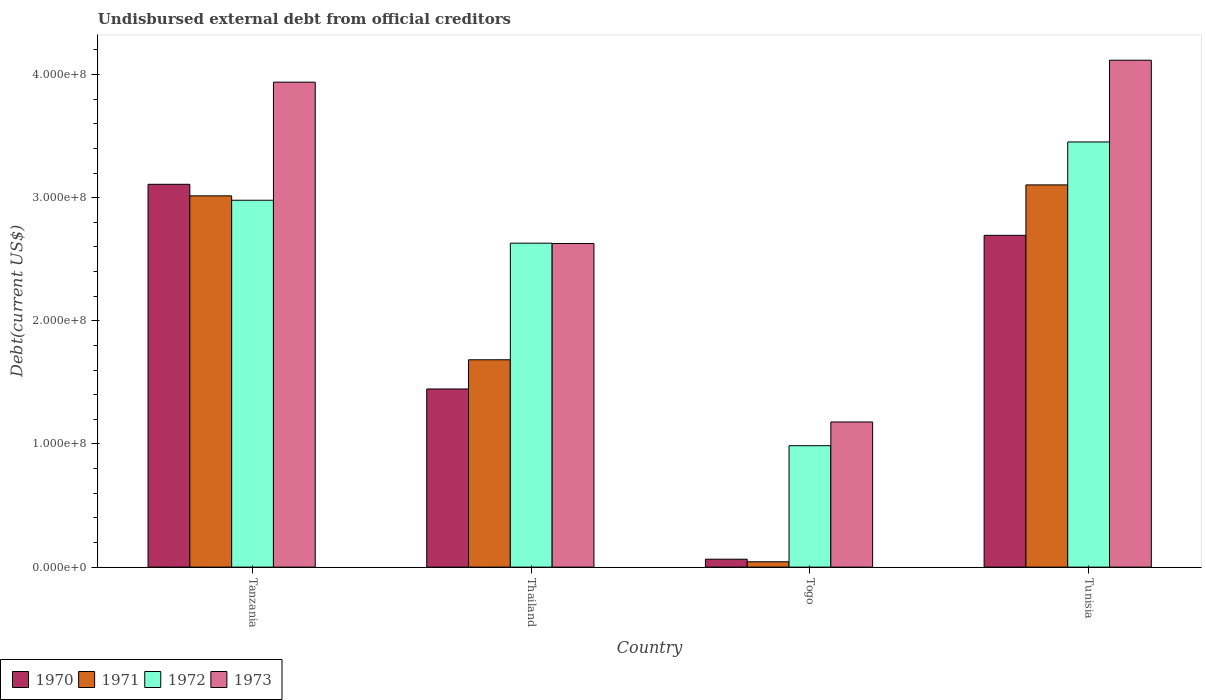How many different coloured bars are there?
Offer a terse response. 4. How many groups of bars are there?
Your answer should be very brief. 4. How many bars are there on the 4th tick from the right?
Ensure brevity in your answer.  4. What is the label of the 4th group of bars from the left?
Your answer should be very brief. Tunisia. In how many cases, is the number of bars for a given country not equal to the number of legend labels?
Your answer should be compact. 0. What is the total debt in 1973 in Tanzania?
Provide a succinct answer. 3.94e+08. Across all countries, what is the maximum total debt in 1973?
Give a very brief answer. 4.12e+08. Across all countries, what is the minimum total debt in 1970?
Offer a very short reply. 6.43e+06. In which country was the total debt in 1970 maximum?
Offer a very short reply. Tanzania. In which country was the total debt in 1971 minimum?
Offer a terse response. Togo. What is the total total debt in 1973 in the graph?
Give a very brief answer. 1.19e+09. What is the difference between the total debt in 1973 in Tanzania and that in Thailand?
Your answer should be very brief. 1.31e+08. What is the difference between the total debt in 1971 in Tanzania and the total debt in 1972 in Thailand?
Provide a short and direct response. 3.84e+07. What is the average total debt in 1970 per country?
Your response must be concise. 1.83e+08. What is the difference between the total debt of/in 1972 and total debt of/in 1970 in Tanzania?
Give a very brief answer. -1.29e+07. In how many countries, is the total debt in 1972 greater than 380000000 US$?
Keep it short and to the point. 0. What is the ratio of the total debt in 1971 in Tanzania to that in Tunisia?
Offer a very short reply. 0.97. Is the difference between the total debt in 1972 in Tanzania and Togo greater than the difference between the total debt in 1970 in Tanzania and Togo?
Your answer should be compact. No. What is the difference between the highest and the second highest total debt in 1973?
Offer a very short reply. 1.49e+08. What is the difference between the highest and the lowest total debt in 1971?
Make the answer very short. 3.06e+08. What does the 2nd bar from the left in Tunisia represents?
Your answer should be compact. 1971. What is the difference between two consecutive major ticks on the Y-axis?
Your answer should be compact. 1.00e+08. Are the values on the major ticks of Y-axis written in scientific E-notation?
Make the answer very short. Yes. What is the title of the graph?
Your answer should be compact. Undisbursed external debt from official creditors. Does "1963" appear as one of the legend labels in the graph?
Make the answer very short. No. What is the label or title of the X-axis?
Keep it short and to the point. Country. What is the label or title of the Y-axis?
Provide a short and direct response. Debt(current US$). What is the Debt(current US$) of 1970 in Tanzania?
Offer a very short reply. 3.11e+08. What is the Debt(current US$) in 1971 in Tanzania?
Make the answer very short. 3.02e+08. What is the Debt(current US$) in 1972 in Tanzania?
Offer a very short reply. 2.98e+08. What is the Debt(current US$) in 1973 in Tanzania?
Offer a very short reply. 3.94e+08. What is the Debt(current US$) in 1970 in Thailand?
Offer a very short reply. 1.45e+08. What is the Debt(current US$) of 1971 in Thailand?
Make the answer very short. 1.68e+08. What is the Debt(current US$) of 1972 in Thailand?
Make the answer very short. 2.63e+08. What is the Debt(current US$) of 1973 in Thailand?
Your answer should be very brief. 2.63e+08. What is the Debt(current US$) in 1970 in Togo?
Make the answer very short. 6.43e+06. What is the Debt(current US$) of 1971 in Togo?
Give a very brief answer. 4.34e+06. What is the Debt(current US$) of 1972 in Togo?
Keep it short and to the point. 9.86e+07. What is the Debt(current US$) of 1973 in Togo?
Keep it short and to the point. 1.18e+08. What is the Debt(current US$) in 1970 in Tunisia?
Provide a succinct answer. 2.69e+08. What is the Debt(current US$) in 1971 in Tunisia?
Your response must be concise. 3.10e+08. What is the Debt(current US$) of 1972 in Tunisia?
Offer a terse response. 3.45e+08. What is the Debt(current US$) of 1973 in Tunisia?
Your answer should be compact. 4.12e+08. Across all countries, what is the maximum Debt(current US$) of 1970?
Your answer should be very brief. 3.11e+08. Across all countries, what is the maximum Debt(current US$) in 1971?
Ensure brevity in your answer.  3.10e+08. Across all countries, what is the maximum Debt(current US$) in 1972?
Provide a short and direct response. 3.45e+08. Across all countries, what is the maximum Debt(current US$) in 1973?
Keep it short and to the point. 4.12e+08. Across all countries, what is the minimum Debt(current US$) in 1970?
Offer a terse response. 6.43e+06. Across all countries, what is the minimum Debt(current US$) of 1971?
Provide a short and direct response. 4.34e+06. Across all countries, what is the minimum Debt(current US$) in 1972?
Give a very brief answer. 9.86e+07. Across all countries, what is the minimum Debt(current US$) in 1973?
Make the answer very short. 1.18e+08. What is the total Debt(current US$) in 1970 in the graph?
Offer a terse response. 7.31e+08. What is the total Debt(current US$) in 1971 in the graph?
Offer a very short reply. 7.85e+08. What is the total Debt(current US$) in 1972 in the graph?
Your response must be concise. 1.00e+09. What is the total Debt(current US$) of 1973 in the graph?
Your answer should be compact. 1.19e+09. What is the difference between the Debt(current US$) of 1970 in Tanzania and that in Thailand?
Offer a terse response. 1.66e+08. What is the difference between the Debt(current US$) of 1971 in Tanzania and that in Thailand?
Your response must be concise. 1.33e+08. What is the difference between the Debt(current US$) in 1972 in Tanzania and that in Thailand?
Your answer should be compact. 3.49e+07. What is the difference between the Debt(current US$) in 1973 in Tanzania and that in Thailand?
Offer a very short reply. 1.31e+08. What is the difference between the Debt(current US$) in 1970 in Tanzania and that in Togo?
Offer a terse response. 3.04e+08. What is the difference between the Debt(current US$) of 1971 in Tanzania and that in Togo?
Provide a short and direct response. 2.97e+08. What is the difference between the Debt(current US$) of 1972 in Tanzania and that in Togo?
Ensure brevity in your answer.  1.99e+08. What is the difference between the Debt(current US$) in 1973 in Tanzania and that in Togo?
Ensure brevity in your answer.  2.76e+08. What is the difference between the Debt(current US$) in 1970 in Tanzania and that in Tunisia?
Keep it short and to the point. 4.14e+07. What is the difference between the Debt(current US$) of 1971 in Tanzania and that in Tunisia?
Provide a short and direct response. -8.90e+06. What is the difference between the Debt(current US$) of 1972 in Tanzania and that in Tunisia?
Your response must be concise. -4.73e+07. What is the difference between the Debt(current US$) of 1973 in Tanzania and that in Tunisia?
Your response must be concise. -1.78e+07. What is the difference between the Debt(current US$) in 1970 in Thailand and that in Togo?
Your response must be concise. 1.38e+08. What is the difference between the Debt(current US$) of 1971 in Thailand and that in Togo?
Offer a very short reply. 1.64e+08. What is the difference between the Debt(current US$) of 1972 in Thailand and that in Togo?
Your answer should be compact. 1.64e+08. What is the difference between the Debt(current US$) in 1973 in Thailand and that in Togo?
Your response must be concise. 1.45e+08. What is the difference between the Debt(current US$) in 1970 in Thailand and that in Tunisia?
Your response must be concise. -1.25e+08. What is the difference between the Debt(current US$) in 1971 in Thailand and that in Tunisia?
Provide a succinct answer. -1.42e+08. What is the difference between the Debt(current US$) of 1972 in Thailand and that in Tunisia?
Provide a succinct answer. -8.22e+07. What is the difference between the Debt(current US$) in 1973 in Thailand and that in Tunisia?
Ensure brevity in your answer.  -1.49e+08. What is the difference between the Debt(current US$) in 1970 in Togo and that in Tunisia?
Ensure brevity in your answer.  -2.63e+08. What is the difference between the Debt(current US$) of 1971 in Togo and that in Tunisia?
Your answer should be compact. -3.06e+08. What is the difference between the Debt(current US$) of 1972 in Togo and that in Tunisia?
Your answer should be very brief. -2.47e+08. What is the difference between the Debt(current US$) of 1973 in Togo and that in Tunisia?
Your answer should be compact. -2.94e+08. What is the difference between the Debt(current US$) of 1970 in Tanzania and the Debt(current US$) of 1971 in Thailand?
Provide a short and direct response. 1.42e+08. What is the difference between the Debt(current US$) in 1970 in Tanzania and the Debt(current US$) in 1972 in Thailand?
Keep it short and to the point. 4.78e+07. What is the difference between the Debt(current US$) in 1970 in Tanzania and the Debt(current US$) in 1973 in Thailand?
Give a very brief answer. 4.81e+07. What is the difference between the Debt(current US$) of 1971 in Tanzania and the Debt(current US$) of 1972 in Thailand?
Your answer should be compact. 3.84e+07. What is the difference between the Debt(current US$) of 1971 in Tanzania and the Debt(current US$) of 1973 in Thailand?
Offer a very short reply. 3.87e+07. What is the difference between the Debt(current US$) of 1972 in Tanzania and the Debt(current US$) of 1973 in Thailand?
Provide a succinct answer. 3.51e+07. What is the difference between the Debt(current US$) in 1970 in Tanzania and the Debt(current US$) in 1971 in Togo?
Your answer should be compact. 3.07e+08. What is the difference between the Debt(current US$) of 1970 in Tanzania and the Debt(current US$) of 1972 in Togo?
Your response must be concise. 2.12e+08. What is the difference between the Debt(current US$) in 1970 in Tanzania and the Debt(current US$) in 1973 in Togo?
Make the answer very short. 1.93e+08. What is the difference between the Debt(current US$) of 1971 in Tanzania and the Debt(current US$) of 1972 in Togo?
Offer a very short reply. 2.03e+08. What is the difference between the Debt(current US$) in 1971 in Tanzania and the Debt(current US$) in 1973 in Togo?
Your answer should be very brief. 1.84e+08. What is the difference between the Debt(current US$) of 1972 in Tanzania and the Debt(current US$) of 1973 in Togo?
Ensure brevity in your answer.  1.80e+08. What is the difference between the Debt(current US$) in 1970 in Tanzania and the Debt(current US$) in 1971 in Tunisia?
Ensure brevity in your answer.  4.74e+05. What is the difference between the Debt(current US$) of 1970 in Tanzania and the Debt(current US$) of 1972 in Tunisia?
Ensure brevity in your answer.  -3.44e+07. What is the difference between the Debt(current US$) in 1970 in Tanzania and the Debt(current US$) in 1973 in Tunisia?
Your answer should be very brief. -1.01e+08. What is the difference between the Debt(current US$) in 1971 in Tanzania and the Debt(current US$) in 1972 in Tunisia?
Provide a succinct answer. -4.38e+07. What is the difference between the Debt(current US$) of 1971 in Tanzania and the Debt(current US$) of 1973 in Tunisia?
Ensure brevity in your answer.  -1.10e+08. What is the difference between the Debt(current US$) in 1972 in Tanzania and the Debt(current US$) in 1973 in Tunisia?
Your answer should be compact. -1.14e+08. What is the difference between the Debt(current US$) in 1970 in Thailand and the Debt(current US$) in 1971 in Togo?
Your answer should be very brief. 1.40e+08. What is the difference between the Debt(current US$) of 1970 in Thailand and the Debt(current US$) of 1972 in Togo?
Offer a very short reply. 4.61e+07. What is the difference between the Debt(current US$) of 1970 in Thailand and the Debt(current US$) of 1973 in Togo?
Provide a succinct answer. 2.68e+07. What is the difference between the Debt(current US$) of 1971 in Thailand and the Debt(current US$) of 1972 in Togo?
Keep it short and to the point. 6.98e+07. What is the difference between the Debt(current US$) of 1971 in Thailand and the Debt(current US$) of 1973 in Togo?
Make the answer very short. 5.05e+07. What is the difference between the Debt(current US$) in 1972 in Thailand and the Debt(current US$) in 1973 in Togo?
Your response must be concise. 1.45e+08. What is the difference between the Debt(current US$) in 1970 in Thailand and the Debt(current US$) in 1971 in Tunisia?
Your response must be concise. -1.66e+08. What is the difference between the Debt(current US$) in 1970 in Thailand and the Debt(current US$) in 1972 in Tunisia?
Keep it short and to the point. -2.01e+08. What is the difference between the Debt(current US$) in 1970 in Thailand and the Debt(current US$) in 1973 in Tunisia?
Ensure brevity in your answer.  -2.67e+08. What is the difference between the Debt(current US$) of 1971 in Thailand and the Debt(current US$) of 1972 in Tunisia?
Your response must be concise. -1.77e+08. What is the difference between the Debt(current US$) in 1971 in Thailand and the Debt(current US$) in 1973 in Tunisia?
Offer a terse response. -2.43e+08. What is the difference between the Debt(current US$) of 1972 in Thailand and the Debt(current US$) of 1973 in Tunisia?
Keep it short and to the point. -1.49e+08. What is the difference between the Debt(current US$) of 1970 in Togo and the Debt(current US$) of 1971 in Tunisia?
Ensure brevity in your answer.  -3.04e+08. What is the difference between the Debt(current US$) of 1970 in Togo and the Debt(current US$) of 1972 in Tunisia?
Your answer should be very brief. -3.39e+08. What is the difference between the Debt(current US$) of 1970 in Togo and the Debt(current US$) of 1973 in Tunisia?
Offer a terse response. -4.05e+08. What is the difference between the Debt(current US$) of 1971 in Togo and the Debt(current US$) of 1972 in Tunisia?
Give a very brief answer. -3.41e+08. What is the difference between the Debt(current US$) in 1971 in Togo and the Debt(current US$) in 1973 in Tunisia?
Your answer should be compact. -4.07e+08. What is the difference between the Debt(current US$) of 1972 in Togo and the Debt(current US$) of 1973 in Tunisia?
Keep it short and to the point. -3.13e+08. What is the average Debt(current US$) of 1970 per country?
Provide a succinct answer. 1.83e+08. What is the average Debt(current US$) in 1971 per country?
Your answer should be very brief. 1.96e+08. What is the average Debt(current US$) in 1972 per country?
Give a very brief answer. 2.51e+08. What is the average Debt(current US$) of 1973 per country?
Make the answer very short. 2.97e+08. What is the difference between the Debt(current US$) in 1970 and Debt(current US$) in 1971 in Tanzania?
Your answer should be compact. 9.37e+06. What is the difference between the Debt(current US$) in 1970 and Debt(current US$) in 1972 in Tanzania?
Your answer should be very brief. 1.29e+07. What is the difference between the Debt(current US$) in 1970 and Debt(current US$) in 1973 in Tanzania?
Your response must be concise. -8.30e+07. What is the difference between the Debt(current US$) of 1971 and Debt(current US$) of 1972 in Tanzania?
Your response must be concise. 3.57e+06. What is the difference between the Debt(current US$) of 1971 and Debt(current US$) of 1973 in Tanzania?
Your response must be concise. -9.23e+07. What is the difference between the Debt(current US$) of 1972 and Debt(current US$) of 1973 in Tanzania?
Your answer should be very brief. -9.59e+07. What is the difference between the Debt(current US$) in 1970 and Debt(current US$) in 1971 in Thailand?
Provide a short and direct response. -2.37e+07. What is the difference between the Debt(current US$) in 1970 and Debt(current US$) in 1972 in Thailand?
Keep it short and to the point. -1.18e+08. What is the difference between the Debt(current US$) of 1970 and Debt(current US$) of 1973 in Thailand?
Offer a very short reply. -1.18e+08. What is the difference between the Debt(current US$) of 1971 and Debt(current US$) of 1972 in Thailand?
Offer a very short reply. -9.47e+07. What is the difference between the Debt(current US$) in 1971 and Debt(current US$) in 1973 in Thailand?
Provide a short and direct response. -9.44e+07. What is the difference between the Debt(current US$) in 1972 and Debt(current US$) in 1973 in Thailand?
Provide a succinct answer. 2.70e+05. What is the difference between the Debt(current US$) of 1970 and Debt(current US$) of 1971 in Togo?
Provide a short and direct response. 2.09e+06. What is the difference between the Debt(current US$) of 1970 and Debt(current US$) of 1972 in Togo?
Your response must be concise. -9.22e+07. What is the difference between the Debt(current US$) in 1970 and Debt(current US$) in 1973 in Togo?
Offer a terse response. -1.11e+08. What is the difference between the Debt(current US$) of 1971 and Debt(current US$) of 1972 in Togo?
Make the answer very short. -9.43e+07. What is the difference between the Debt(current US$) of 1971 and Debt(current US$) of 1973 in Togo?
Provide a short and direct response. -1.14e+08. What is the difference between the Debt(current US$) in 1972 and Debt(current US$) in 1973 in Togo?
Provide a succinct answer. -1.93e+07. What is the difference between the Debt(current US$) of 1970 and Debt(current US$) of 1971 in Tunisia?
Provide a succinct answer. -4.10e+07. What is the difference between the Debt(current US$) of 1970 and Debt(current US$) of 1972 in Tunisia?
Provide a short and direct response. -7.58e+07. What is the difference between the Debt(current US$) of 1970 and Debt(current US$) of 1973 in Tunisia?
Offer a very short reply. -1.42e+08. What is the difference between the Debt(current US$) of 1971 and Debt(current US$) of 1972 in Tunisia?
Offer a very short reply. -3.49e+07. What is the difference between the Debt(current US$) of 1971 and Debt(current US$) of 1973 in Tunisia?
Keep it short and to the point. -1.01e+08. What is the difference between the Debt(current US$) in 1972 and Debt(current US$) in 1973 in Tunisia?
Offer a terse response. -6.64e+07. What is the ratio of the Debt(current US$) of 1970 in Tanzania to that in Thailand?
Offer a terse response. 2.15. What is the ratio of the Debt(current US$) of 1971 in Tanzania to that in Thailand?
Your response must be concise. 1.79. What is the ratio of the Debt(current US$) in 1972 in Tanzania to that in Thailand?
Your response must be concise. 1.13. What is the ratio of the Debt(current US$) of 1973 in Tanzania to that in Thailand?
Ensure brevity in your answer.  1.5. What is the ratio of the Debt(current US$) of 1970 in Tanzania to that in Togo?
Offer a terse response. 48.37. What is the ratio of the Debt(current US$) of 1971 in Tanzania to that in Togo?
Keep it short and to the point. 69.54. What is the ratio of the Debt(current US$) of 1972 in Tanzania to that in Togo?
Offer a very short reply. 3.02. What is the ratio of the Debt(current US$) of 1973 in Tanzania to that in Togo?
Keep it short and to the point. 3.34. What is the ratio of the Debt(current US$) of 1970 in Tanzania to that in Tunisia?
Provide a short and direct response. 1.15. What is the ratio of the Debt(current US$) in 1971 in Tanzania to that in Tunisia?
Offer a very short reply. 0.97. What is the ratio of the Debt(current US$) of 1972 in Tanzania to that in Tunisia?
Provide a succinct answer. 0.86. What is the ratio of the Debt(current US$) in 1973 in Tanzania to that in Tunisia?
Provide a succinct answer. 0.96. What is the ratio of the Debt(current US$) in 1970 in Thailand to that in Togo?
Ensure brevity in your answer.  22.51. What is the ratio of the Debt(current US$) of 1971 in Thailand to that in Togo?
Provide a succinct answer. 38.84. What is the ratio of the Debt(current US$) in 1972 in Thailand to that in Togo?
Offer a terse response. 2.67. What is the ratio of the Debt(current US$) of 1973 in Thailand to that in Togo?
Offer a very short reply. 2.23. What is the ratio of the Debt(current US$) in 1970 in Thailand to that in Tunisia?
Keep it short and to the point. 0.54. What is the ratio of the Debt(current US$) in 1971 in Thailand to that in Tunisia?
Provide a succinct answer. 0.54. What is the ratio of the Debt(current US$) in 1972 in Thailand to that in Tunisia?
Provide a short and direct response. 0.76. What is the ratio of the Debt(current US$) of 1973 in Thailand to that in Tunisia?
Provide a succinct answer. 0.64. What is the ratio of the Debt(current US$) in 1970 in Togo to that in Tunisia?
Make the answer very short. 0.02. What is the ratio of the Debt(current US$) in 1971 in Togo to that in Tunisia?
Provide a short and direct response. 0.01. What is the ratio of the Debt(current US$) of 1972 in Togo to that in Tunisia?
Provide a short and direct response. 0.29. What is the ratio of the Debt(current US$) in 1973 in Togo to that in Tunisia?
Your answer should be very brief. 0.29. What is the difference between the highest and the second highest Debt(current US$) of 1970?
Ensure brevity in your answer.  4.14e+07. What is the difference between the highest and the second highest Debt(current US$) of 1971?
Give a very brief answer. 8.90e+06. What is the difference between the highest and the second highest Debt(current US$) of 1972?
Keep it short and to the point. 4.73e+07. What is the difference between the highest and the second highest Debt(current US$) in 1973?
Provide a short and direct response. 1.78e+07. What is the difference between the highest and the lowest Debt(current US$) of 1970?
Keep it short and to the point. 3.04e+08. What is the difference between the highest and the lowest Debt(current US$) in 1971?
Your answer should be compact. 3.06e+08. What is the difference between the highest and the lowest Debt(current US$) in 1972?
Make the answer very short. 2.47e+08. What is the difference between the highest and the lowest Debt(current US$) in 1973?
Keep it short and to the point. 2.94e+08. 